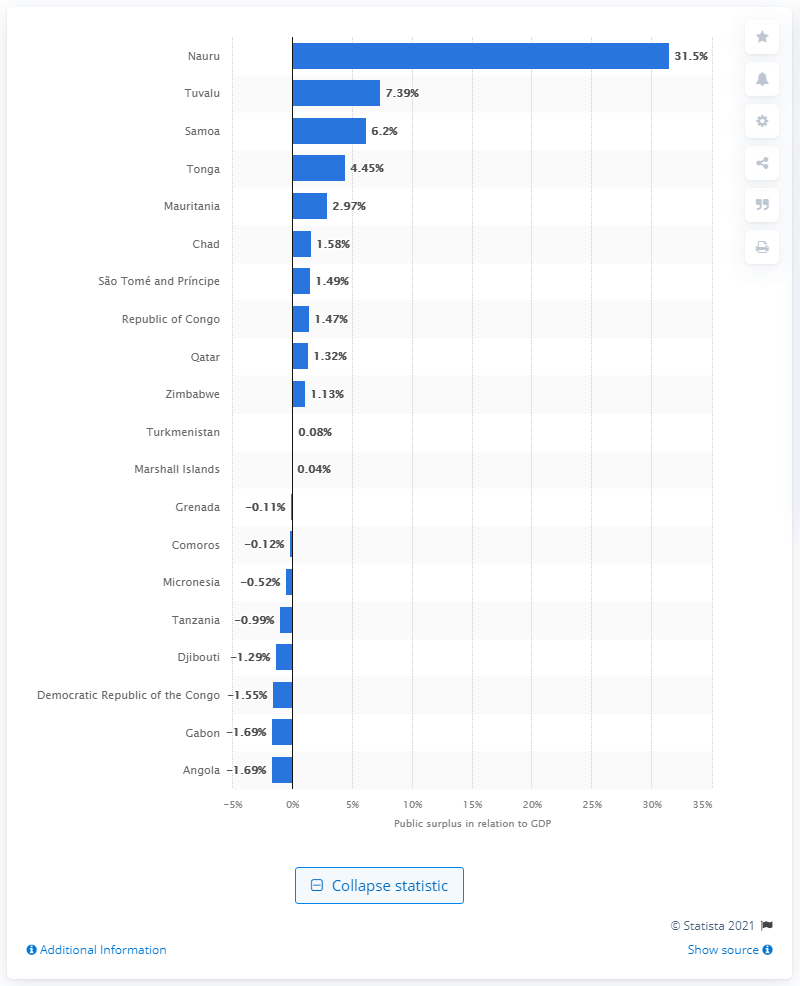Highlight a few significant elements in this photo. In 2020, Nauru's surplus as a percentage of its gross domestic product was 31.5%. Nauru ranked first among countries with the highest public surplus in 2020. 